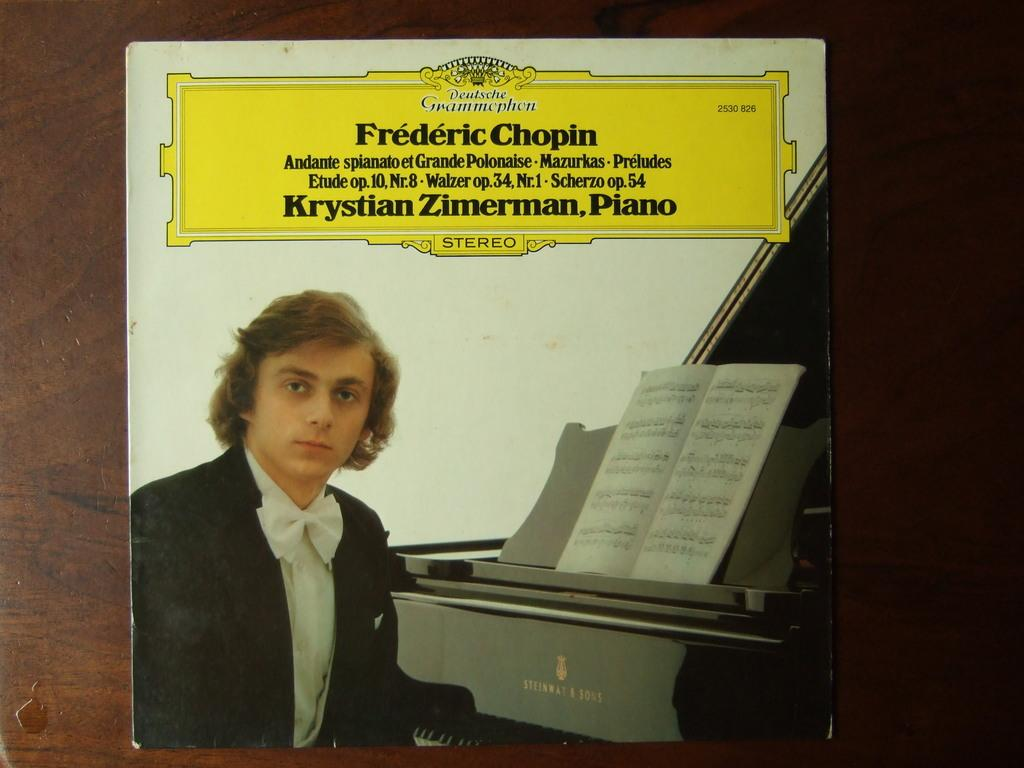<image>
Give a short and clear explanation of the subsequent image. A CD cover of a collection of Frederic Chopin music. 